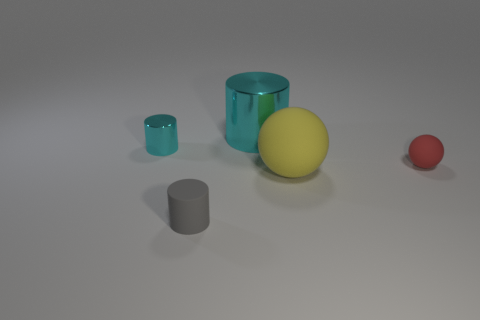Subtract all cyan balls. How many cyan cylinders are left? 2 Add 3 big cyan things. How many objects exist? 8 Subtract all cyan shiny things. Subtract all cyan shiny objects. How many objects are left? 1 Add 2 tiny cyan cylinders. How many tiny cyan cylinders are left? 3 Add 2 shiny cylinders. How many shiny cylinders exist? 4 Subtract 0 green cylinders. How many objects are left? 5 Subtract all cylinders. How many objects are left? 2 